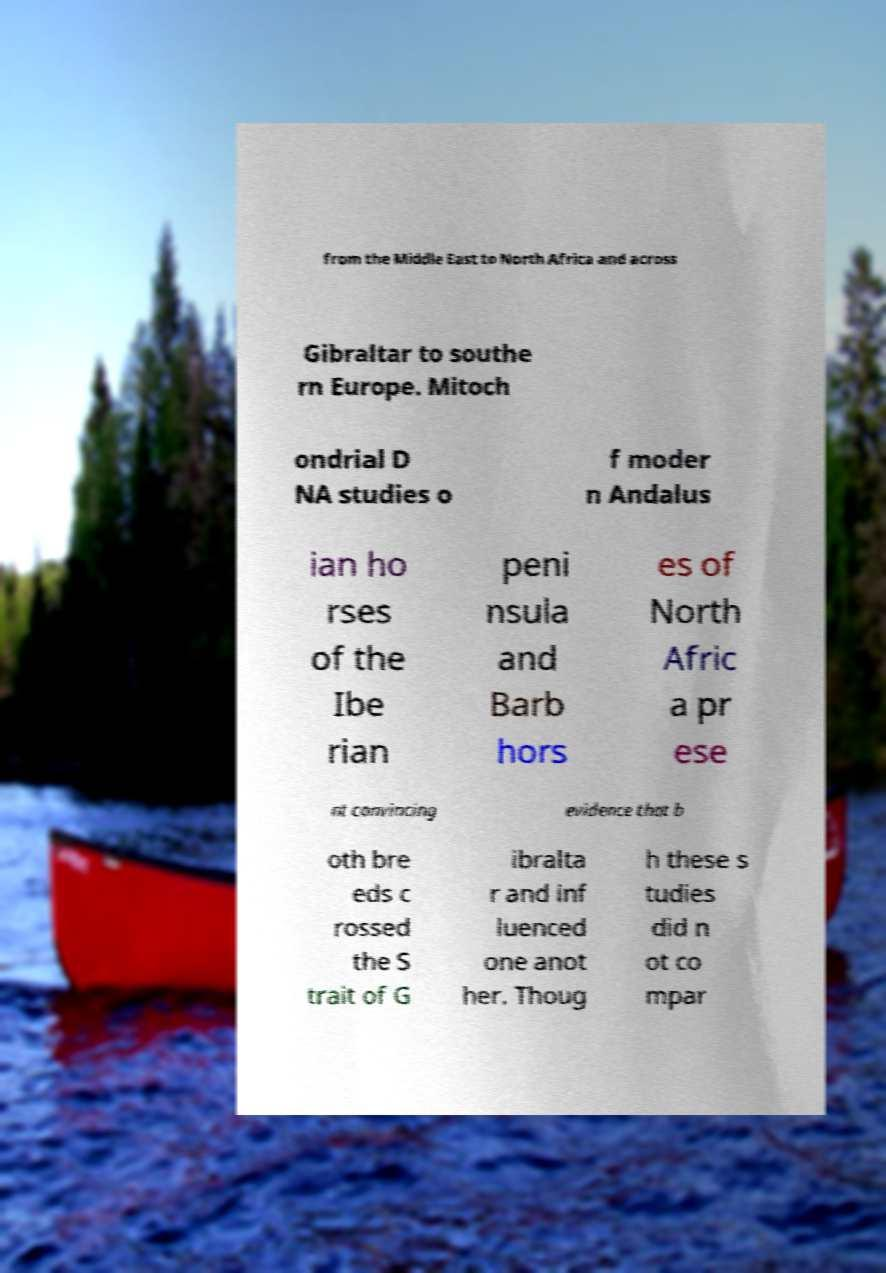Please identify and transcribe the text found in this image. from the Middle East to North Africa and across Gibraltar to southe rn Europe. Mitoch ondrial D NA studies o f moder n Andalus ian ho rses of the Ibe rian peni nsula and Barb hors es of North Afric a pr ese nt convincing evidence that b oth bre eds c rossed the S trait of G ibralta r and inf luenced one anot her. Thoug h these s tudies did n ot co mpar 